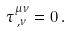<formula> <loc_0><loc_0><loc_500><loc_500>\tau ^ { \mu \nu } _ { \, , \nu } = 0 \, .</formula> 